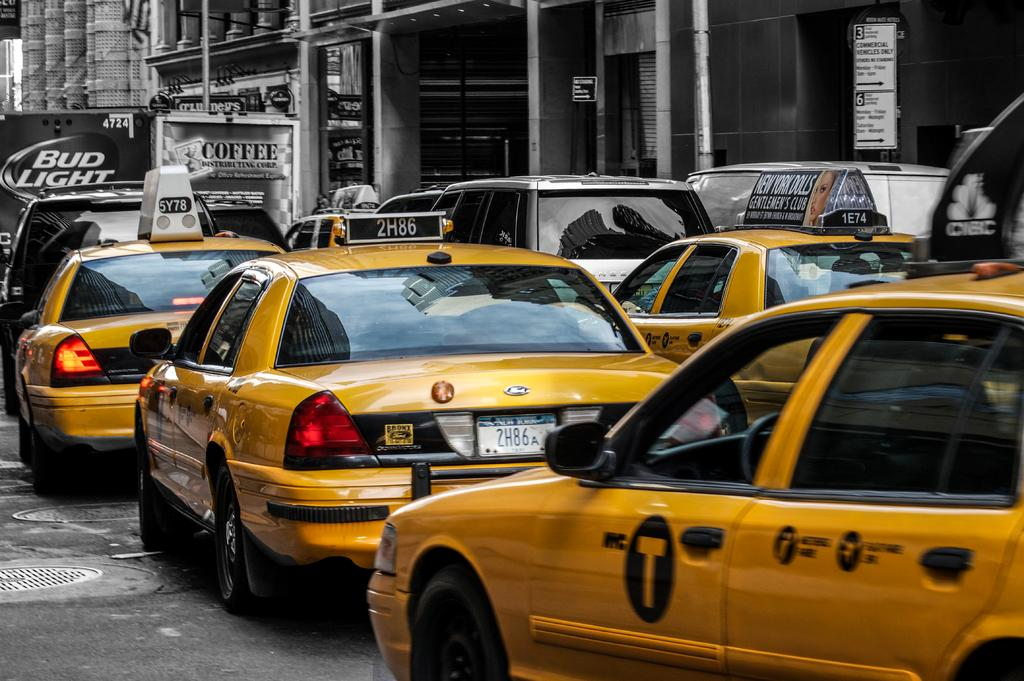<image>
Summarize the visual content of the image. A Bud Light truck is blocking the road 